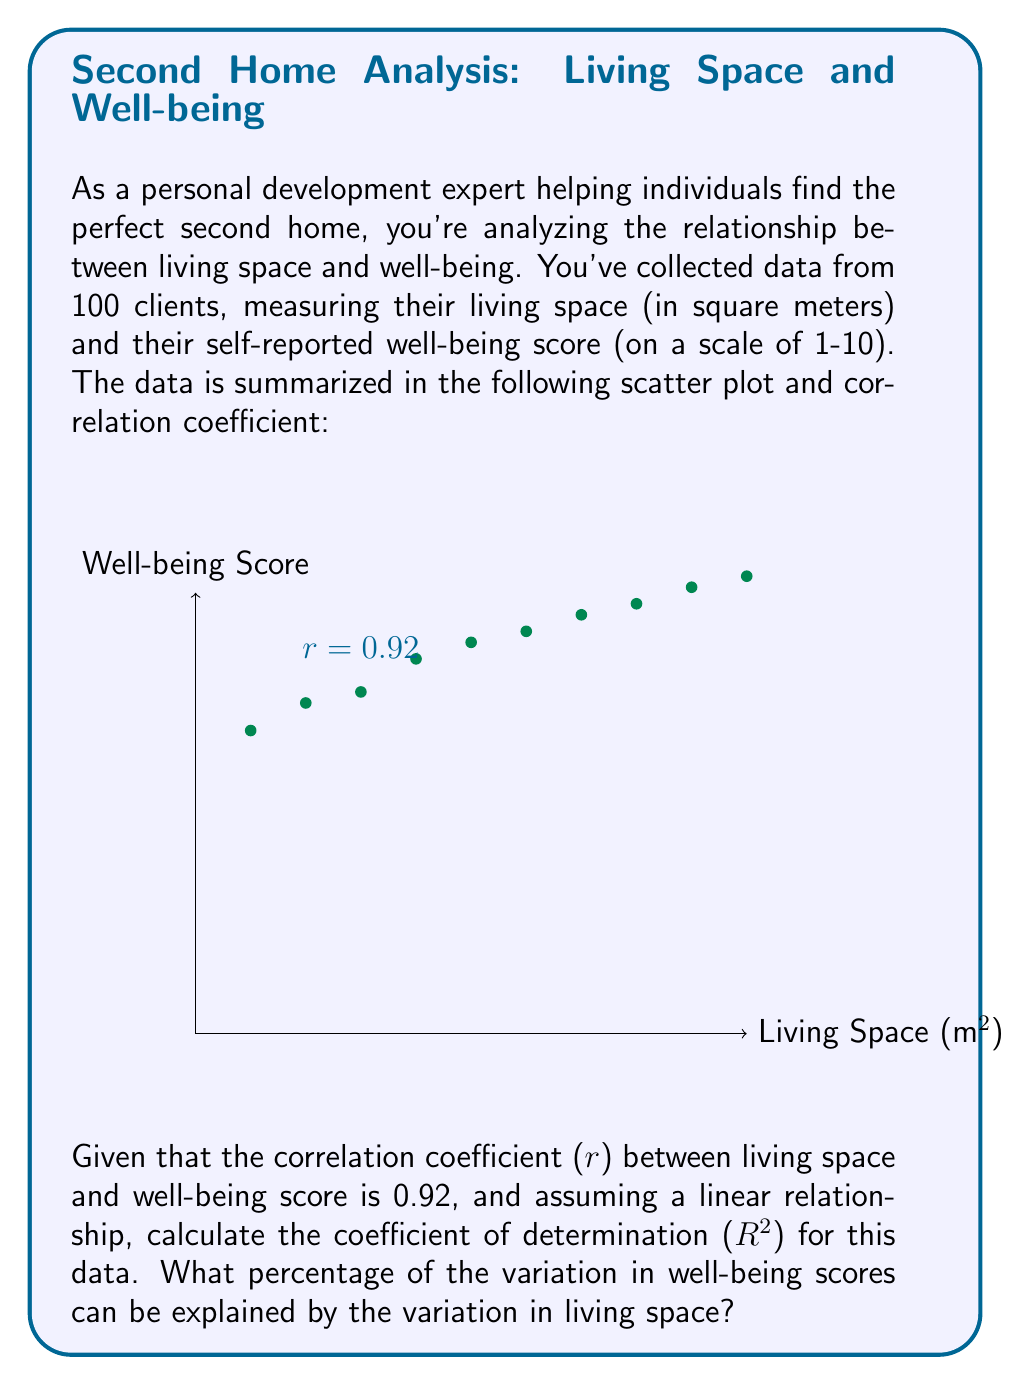What is the answer to this math problem? To solve this problem, we need to follow these steps:

1. Recall that the coefficient of determination (R²) is the square of the correlation coefficient (r) for a simple linear regression.

2. We are given that r = 0.92.

3. Calculate R² by squaring r:

   $$R^2 = r^2 = (0.92)^2 = 0.8464$$

4. To express this as a percentage, multiply by 100:

   $$0.8464 \times 100 = 84.64\%$$

5. Interpret the result: 84.64% of the variation in well-being scores can be explained by the variation in living space.

This high R² value indicates a strong relationship between living space and well-being, which is valuable information for a personal development expert helping clients find an ideal second home. It suggests that increasing living space is likely to have a positive impact on a client's well-being, although other factors not accounted for in this model explain the remaining 15.36% of variation in well-being scores.
Answer: 84.64% 